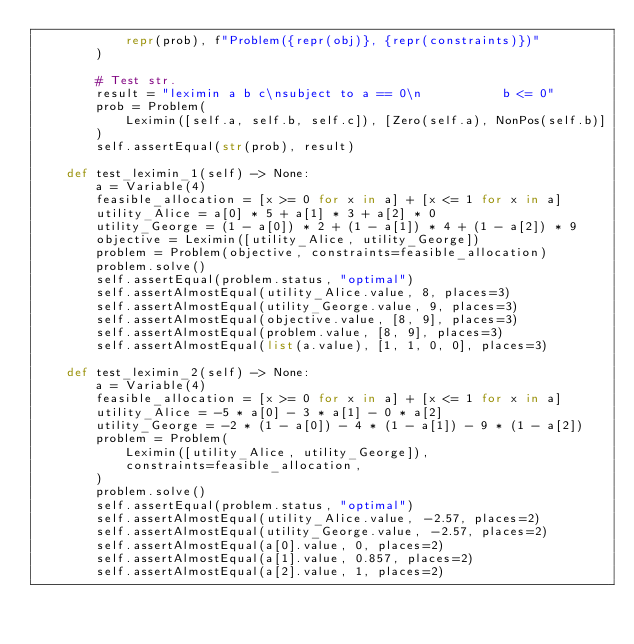<code> <loc_0><loc_0><loc_500><loc_500><_Python_>            repr(prob), f"Problem({repr(obj)}, {repr(constraints)})"
        )

        # Test str.
        result = "leximin a b c\nsubject to a == 0\n           b <= 0"
        prob = Problem(
            Leximin([self.a, self.b, self.c]), [Zero(self.a), NonPos(self.b)]
        )
        self.assertEqual(str(prob), result)

    def test_leximin_1(self) -> None:
        a = Variable(4)
        feasible_allocation = [x >= 0 for x in a] + [x <= 1 for x in a]
        utility_Alice = a[0] * 5 + a[1] * 3 + a[2] * 0
        utility_George = (1 - a[0]) * 2 + (1 - a[1]) * 4 + (1 - a[2]) * 9
        objective = Leximin([utility_Alice, utility_George])
        problem = Problem(objective, constraints=feasible_allocation)
        problem.solve()
        self.assertEqual(problem.status, "optimal")
        self.assertAlmostEqual(utility_Alice.value, 8, places=3)
        self.assertAlmostEqual(utility_George.value, 9, places=3)
        self.assertAlmostEqual(objective.value, [8, 9], places=3)
        self.assertAlmostEqual(problem.value, [8, 9], places=3)
        self.assertAlmostEqual(list(a.value), [1, 1, 0, 0], places=3)

    def test_leximin_2(self) -> None:
        a = Variable(4)
        feasible_allocation = [x >= 0 for x in a] + [x <= 1 for x in a]
        utility_Alice = -5 * a[0] - 3 * a[1] - 0 * a[2]
        utility_George = -2 * (1 - a[0]) - 4 * (1 - a[1]) - 9 * (1 - a[2])
        problem = Problem(
            Leximin([utility_Alice, utility_George]),
            constraints=feasible_allocation,
        )
        problem.solve()
        self.assertEqual(problem.status, "optimal")
        self.assertAlmostEqual(utility_Alice.value, -2.57, places=2)
        self.assertAlmostEqual(utility_George.value, -2.57, places=2)
        self.assertAlmostEqual(a[0].value, 0, places=2)
        self.assertAlmostEqual(a[1].value, 0.857, places=2)
        self.assertAlmostEqual(a[2].value, 1, places=2)</code> 